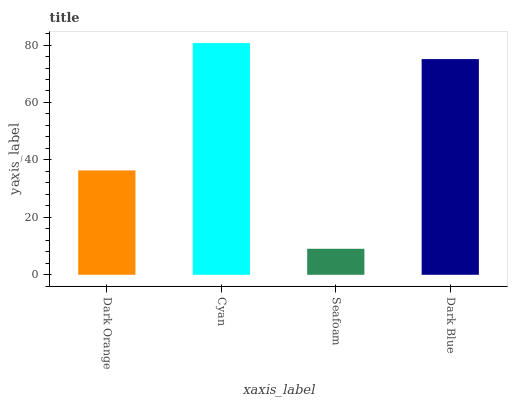Is Seafoam the minimum?
Answer yes or no. Yes. Is Cyan the maximum?
Answer yes or no. Yes. Is Cyan the minimum?
Answer yes or no. No. Is Seafoam the maximum?
Answer yes or no. No. Is Cyan greater than Seafoam?
Answer yes or no. Yes. Is Seafoam less than Cyan?
Answer yes or no. Yes. Is Seafoam greater than Cyan?
Answer yes or no. No. Is Cyan less than Seafoam?
Answer yes or no. No. Is Dark Blue the high median?
Answer yes or no. Yes. Is Dark Orange the low median?
Answer yes or no. Yes. Is Dark Orange the high median?
Answer yes or no. No. Is Cyan the low median?
Answer yes or no. No. 